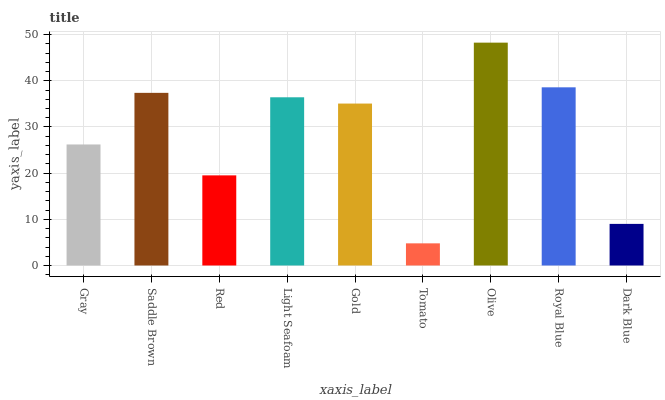Is Tomato the minimum?
Answer yes or no. Yes. Is Olive the maximum?
Answer yes or no. Yes. Is Saddle Brown the minimum?
Answer yes or no. No. Is Saddle Brown the maximum?
Answer yes or no. No. Is Saddle Brown greater than Gray?
Answer yes or no. Yes. Is Gray less than Saddle Brown?
Answer yes or no. Yes. Is Gray greater than Saddle Brown?
Answer yes or no. No. Is Saddle Brown less than Gray?
Answer yes or no. No. Is Gold the high median?
Answer yes or no. Yes. Is Gold the low median?
Answer yes or no. Yes. Is Gray the high median?
Answer yes or no. No. Is Dark Blue the low median?
Answer yes or no. No. 